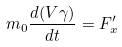<formula> <loc_0><loc_0><loc_500><loc_500>m _ { 0 } \frac { d ( V \gamma ) } { d t } = F _ { x } ^ { \prime }</formula> 